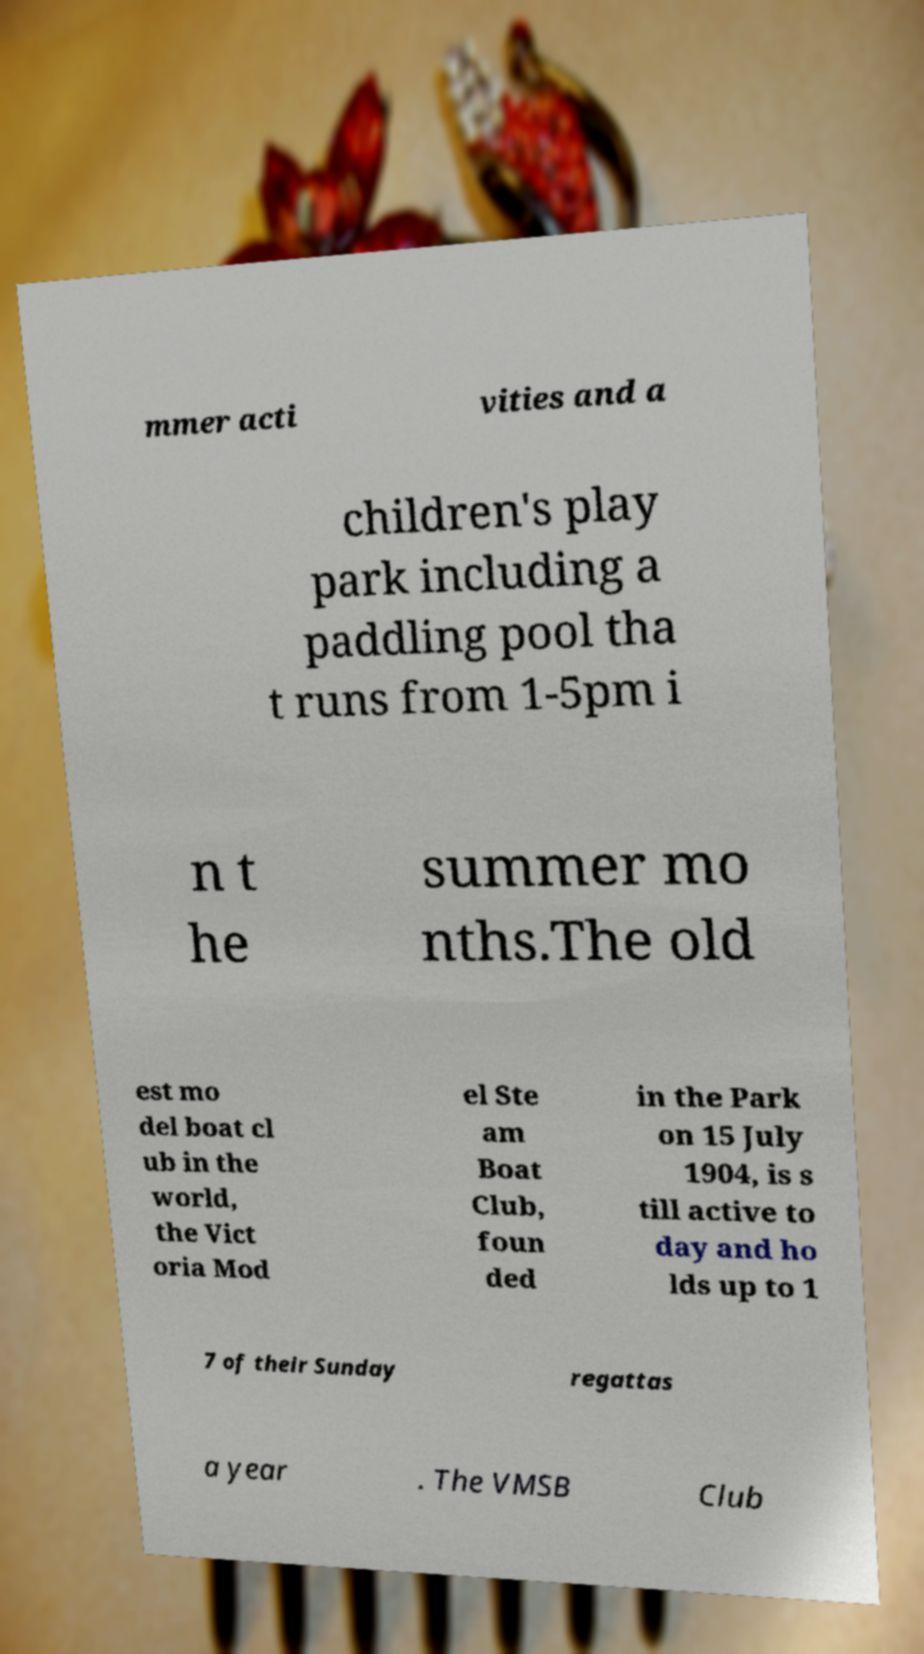There's text embedded in this image that I need extracted. Can you transcribe it verbatim? mmer acti vities and a children's play park including a paddling pool tha t runs from 1-5pm i n t he summer mo nths.The old est mo del boat cl ub in the world, the Vict oria Mod el Ste am Boat Club, foun ded in the Park on 15 July 1904, is s till active to day and ho lds up to 1 7 of their Sunday regattas a year . The VMSB Club 